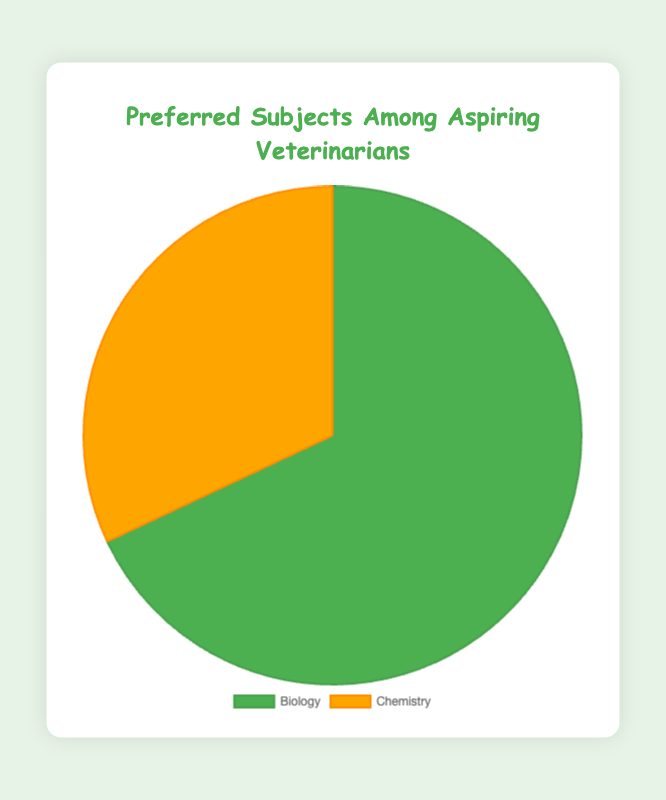What are the preferred subjects among aspiring veterinarians? By looking at the pie chart, we can see that the two subjects are Biology and Chemistry.
Answer: Biology and Chemistry Which subject is more preferred among aspiring veterinarians? The pie chart shows that Biology has a larger section compared to Chemistry.
Answer: Biology What percentage of aspiring veterinarians prefer Chemistry? The pie chart specifically shows that Chemistry makes up 32% of the total.
Answer: 32% If you combine the percentages for Biology and Chemistry, what is the total? Adding the percentage of Biology (68%) to that of Chemistry (32%) gives 68% + 32% = 100%.
Answer: 100% How much more popular is Biology compared to Chemistry in terms of percentage? Biology is 68% while Chemistry is 32%, so the difference is 68% - 32% = 36%.
Answer: 36% Which section is represented by a green color in the pie chart? From the description of the chart, Biology is associated with the green color.
Answer: Biology What is the approximate ratio of students preferring Biology to those preferring Chemistry? The percentage for Biology is 68% and for Chemistry is 32%. The ratio is 68:32, which simplifies to approximately 2.13:1 (or roughly 2:1 when rounded).
Answer: 2:1 If 100 aspiring veterinarians were surveyed, how many would prefer Biology? With 68% of aspiring veterinarians preferring Biology, in a group of 100, that would be 100 * 0.68 = 68.
Answer: 68 What would be the difference in the number of students preferring Biology versus Chemistry if there were 150 students surveyed? 68% of 150 = 0.68 * 150 = 102 students for Biology. 32% of 150 = 0.32 * 150 = 48 students for Chemistry. The difference is 102 - 48 = 54 students.
Answer: 54 